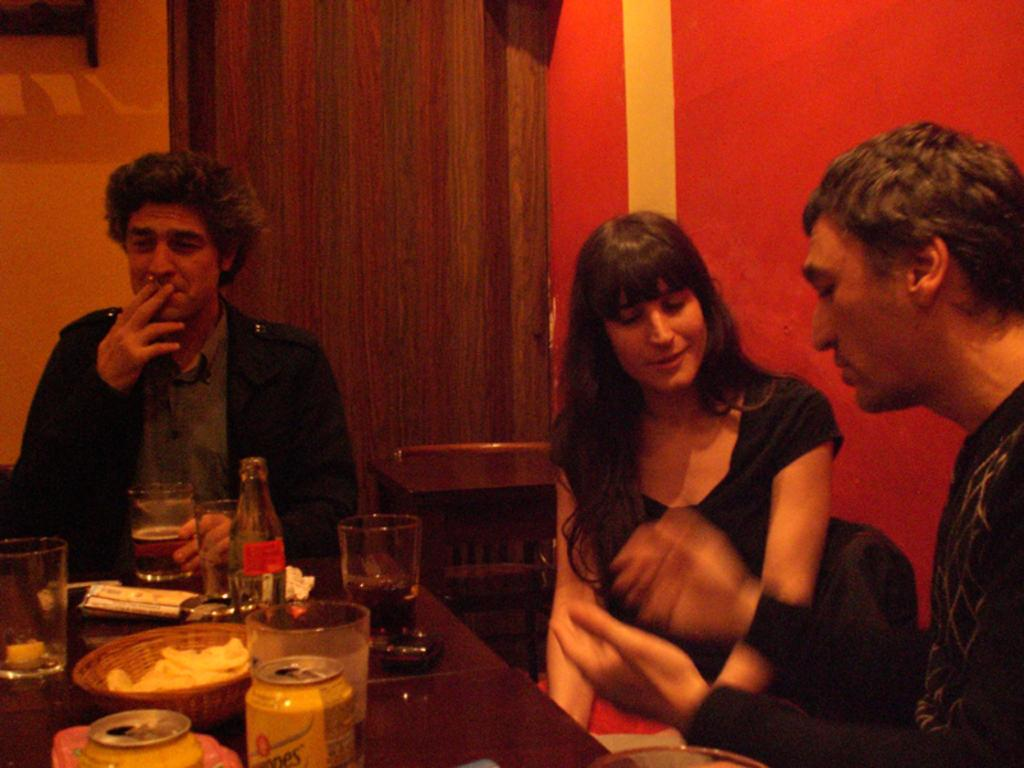How many people are sitting in the image? There are three persons sitting on chairs in the image. What is present on the table in the image? There are glasses, a bottle, a tin, and a bowl on the table in the image. What can be seen in the background of the image? There is a wall and a door in the background of the image. What type of cloth is being used for teaching in the image? There is no cloth or teaching activity present in the image. Are there any police officers visible in the image? There are no police officers visible in the image. 